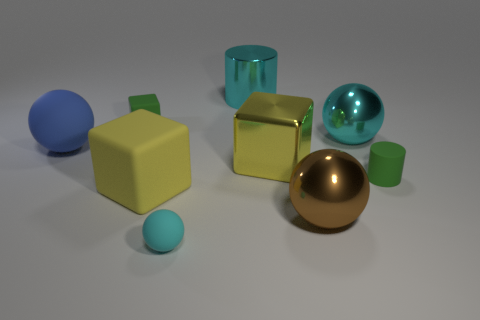Are there fewer big matte balls that are behind the blue matte ball than big yellow shiny spheres?
Provide a succinct answer. No. The big cyan object that is to the right of the cylinder that is left of the big yellow block that is right of the large yellow matte thing is what shape?
Provide a short and direct response. Sphere. Does the brown metallic thing have the same shape as the yellow metallic thing?
Keep it short and to the point. No. How many other objects are the same shape as the tiny cyan rubber object?
Your answer should be very brief. 3. What is the color of the matte ball that is the same size as the metallic block?
Ensure brevity in your answer.  Blue. Is the number of large metallic spheres in front of the blue rubber sphere the same as the number of big blue balls?
Ensure brevity in your answer.  Yes. There is a big object that is both behind the brown metallic object and in front of the green cylinder; what shape is it?
Provide a short and direct response. Cube. Do the yellow matte object and the cyan shiny cylinder have the same size?
Offer a very short reply. Yes. Is there another tiny block made of the same material as the small green block?
Your answer should be very brief. No. The other metallic ball that is the same color as the tiny sphere is what size?
Offer a very short reply. Large. 